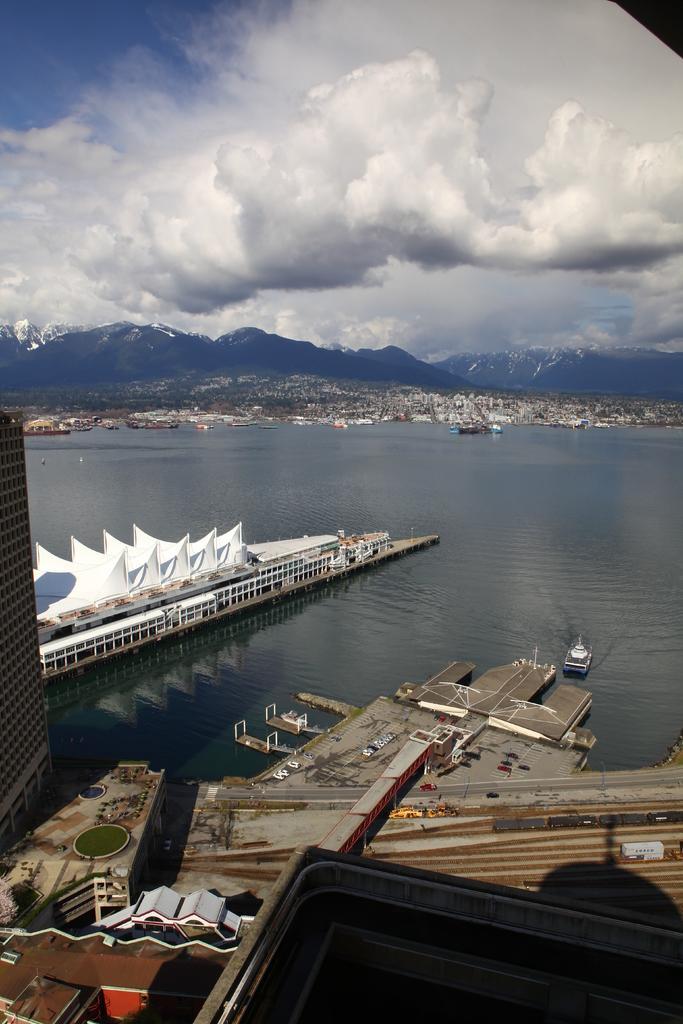In one or two sentences, can you explain what this image depicts? In the foreground I can see buildings, roads and boats in the water. In the background I can see houses, trees and mountains. At the top I can see the sky. This image is taken may be near the lake. 